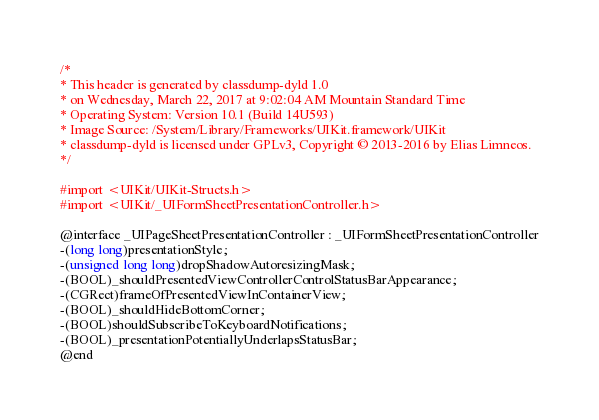<code> <loc_0><loc_0><loc_500><loc_500><_C_>/*
* This header is generated by classdump-dyld 1.0
* on Wednesday, March 22, 2017 at 9:02:04 AM Mountain Standard Time
* Operating System: Version 10.1 (Build 14U593)
* Image Source: /System/Library/Frameworks/UIKit.framework/UIKit
* classdump-dyld is licensed under GPLv3, Copyright © 2013-2016 by Elias Limneos.
*/

#import <UIKit/UIKit-Structs.h>
#import <UIKit/_UIFormSheetPresentationController.h>

@interface _UIPageSheetPresentationController : _UIFormSheetPresentationController
-(long long)presentationStyle;
-(unsigned long long)dropShadowAutoresizingMask;
-(BOOL)_shouldPresentedViewControllerControlStatusBarAppearance;
-(CGRect)frameOfPresentedViewInContainerView;
-(BOOL)_shouldHideBottomCorner;
-(BOOL)shouldSubscribeToKeyboardNotifications;
-(BOOL)_presentationPotentiallyUnderlapsStatusBar;
@end

</code> 